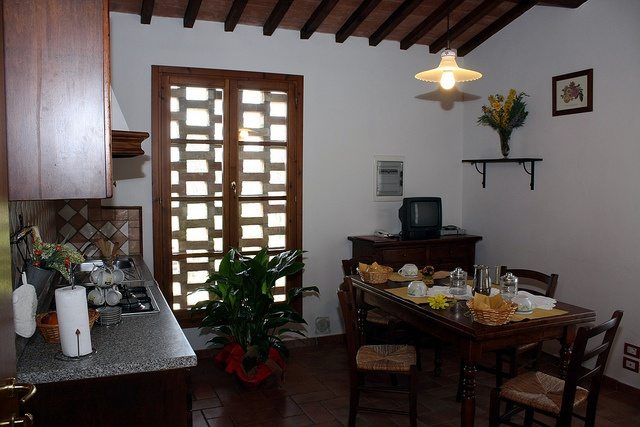Describe the objects in this image and their specific colors. I can see potted plant in black, gray, white, and maroon tones, dining table in black, maroon, and gray tones, chair in black, maroon, and gray tones, chair in black, gray, and maroon tones, and chair in black and gray tones in this image. 